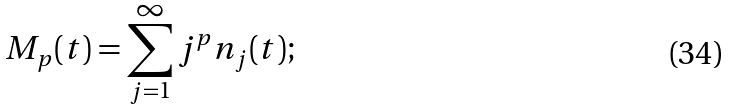<formula> <loc_0><loc_0><loc_500><loc_500>M _ { p } ( t ) = \sum _ { j = 1 } ^ { \infty } j ^ { p } n _ { j } ( t ) ;</formula> 